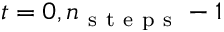Convert formula to latex. <formula><loc_0><loc_0><loc_500><loc_500>t = 0 , n _ { s t e p s } - 1</formula> 